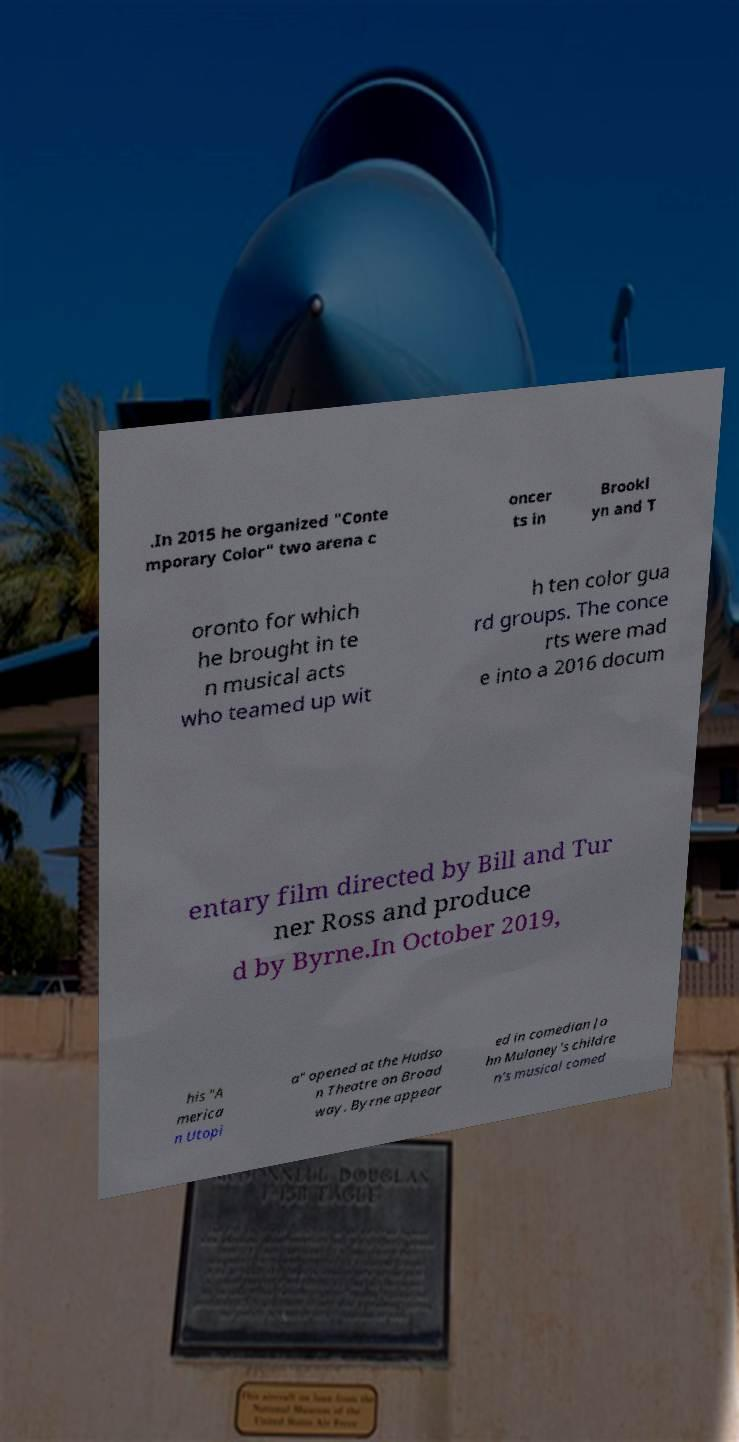Could you assist in decoding the text presented in this image and type it out clearly? .In 2015 he organized "Conte mporary Color" two arena c oncer ts in Brookl yn and T oronto for which he brought in te n musical acts who teamed up wit h ten color gua rd groups. The conce rts were mad e into a 2016 docum entary film directed by Bill and Tur ner Ross and produce d by Byrne.In October 2019, his "A merica n Utopi a" opened at the Hudso n Theatre on Broad way. Byrne appear ed in comedian Jo hn Mulaney's childre n's musical comed 